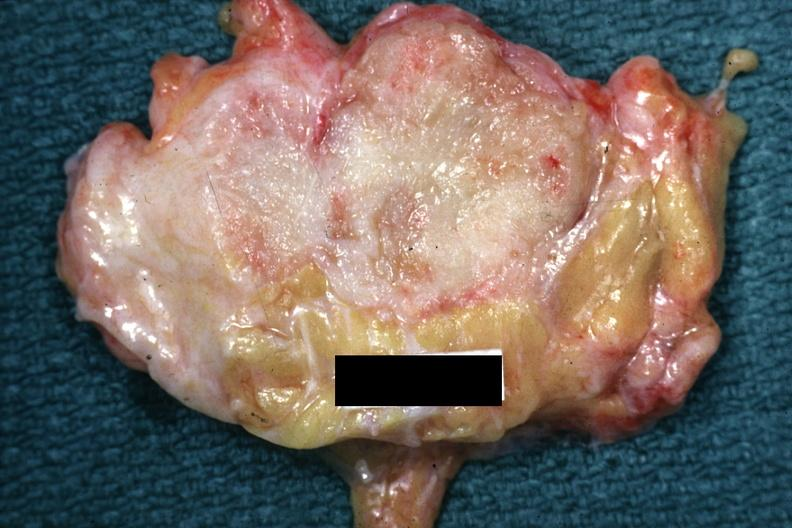does this image show good example of a breast carcinoma?
Answer the question using a single word or phrase. Yes 